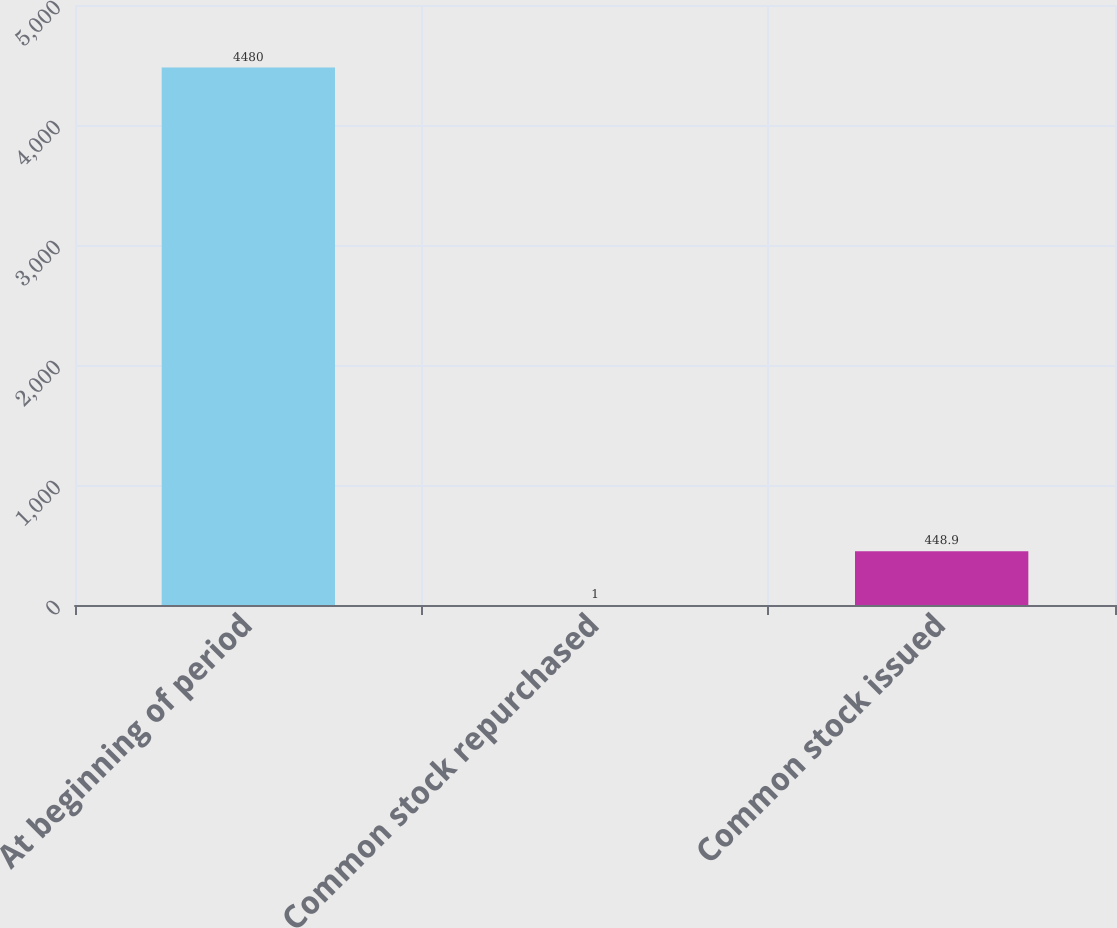Convert chart to OTSL. <chart><loc_0><loc_0><loc_500><loc_500><bar_chart><fcel>At beginning of period<fcel>Common stock repurchased<fcel>Common stock issued<nl><fcel>4480<fcel>1<fcel>448.9<nl></chart> 